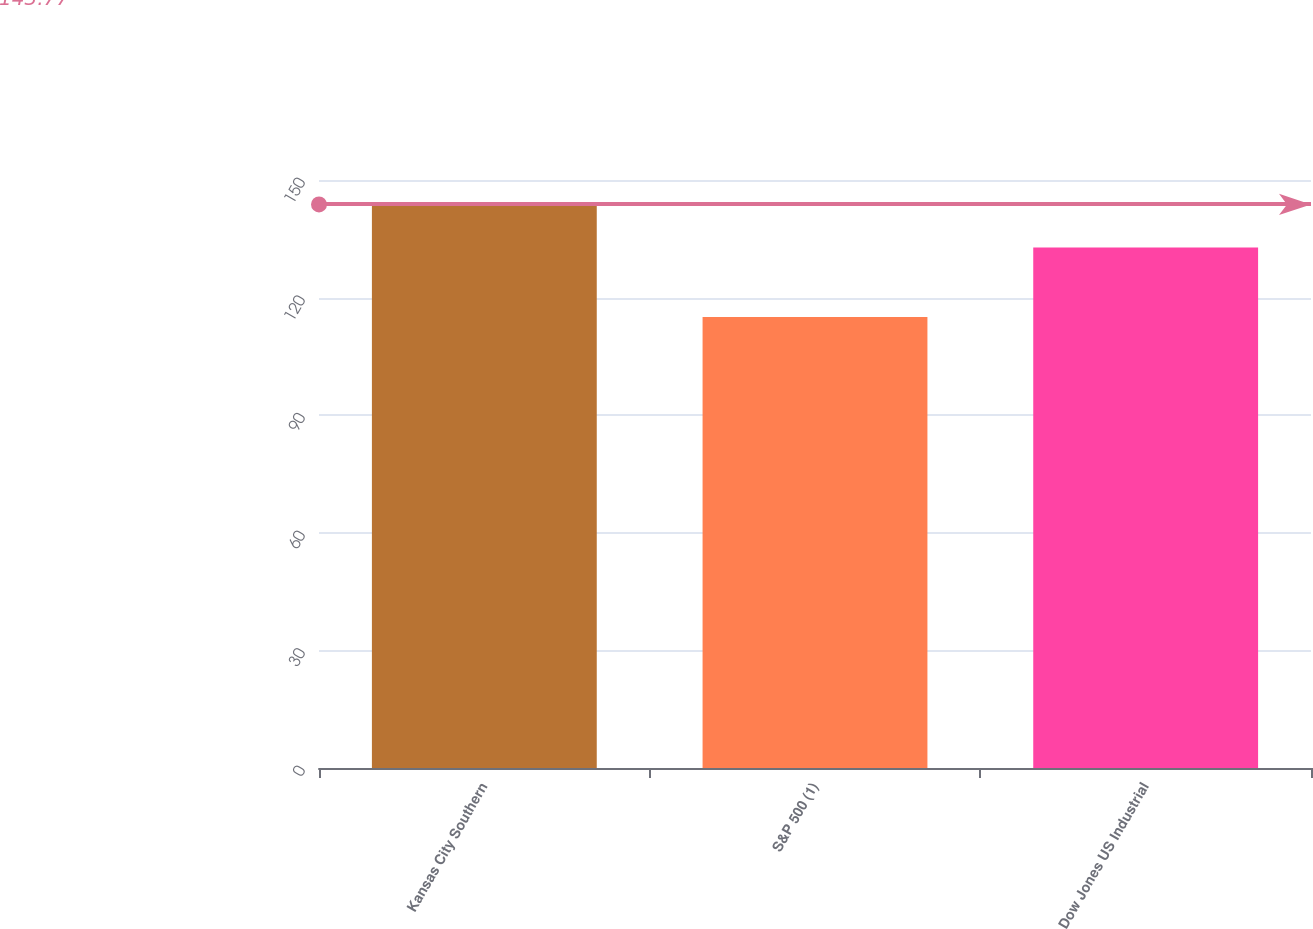<chart> <loc_0><loc_0><loc_500><loc_500><bar_chart><fcel>Kansas City Southern<fcel>S&P 500 (1)<fcel>Dow Jones US Industrial<nl><fcel>143.77<fcel>115.06<fcel>132.77<nl></chart> 